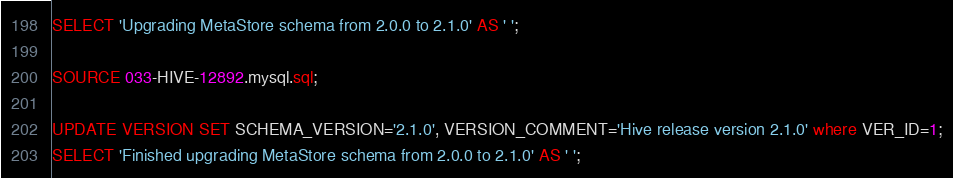<code> <loc_0><loc_0><loc_500><loc_500><_SQL_>SELECT 'Upgrading MetaStore schema from 2.0.0 to 2.1.0' AS ' ';

SOURCE 033-HIVE-12892.mysql.sql;

UPDATE VERSION SET SCHEMA_VERSION='2.1.0', VERSION_COMMENT='Hive release version 2.1.0' where VER_ID=1;
SELECT 'Finished upgrading MetaStore schema from 2.0.0 to 2.1.0' AS ' ';

</code> 